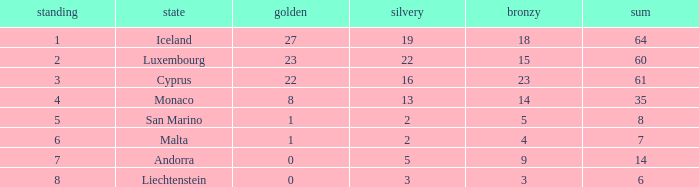Could you parse the entire table? {'header': ['standing', 'state', 'golden', 'silvery', 'bronzy', 'sum'], 'rows': [['1', 'Iceland', '27', '19', '18', '64'], ['2', 'Luxembourg', '23', '22', '15', '60'], ['3', 'Cyprus', '22', '16', '23', '61'], ['4', 'Monaco', '8', '13', '14', '35'], ['5', 'San Marino', '1', '2', '5', '8'], ['6', 'Malta', '1', '2', '4', '7'], ['7', 'Andorra', '0', '5', '9', '14'], ['8', 'Liechtenstein', '0', '3', '3', '6']]} How many golds for the nation with 14 total? 0.0. 